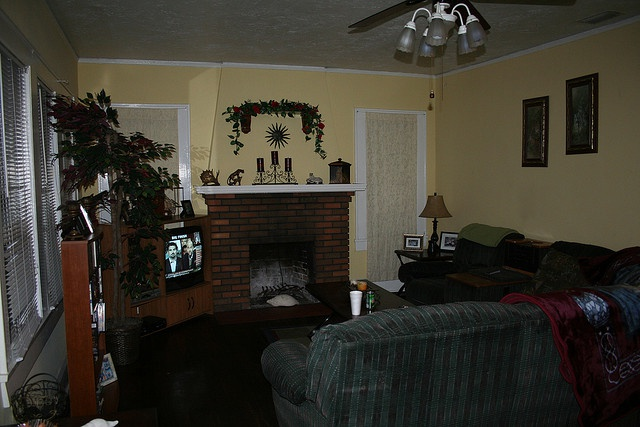Describe the objects in this image and their specific colors. I can see couch in black and gray tones, couch in black, gray, and maroon tones, chair in black, gray, and darkgreen tones, potted plant in black and gray tones, and tv in black, gray, darkgray, and lightblue tones in this image. 